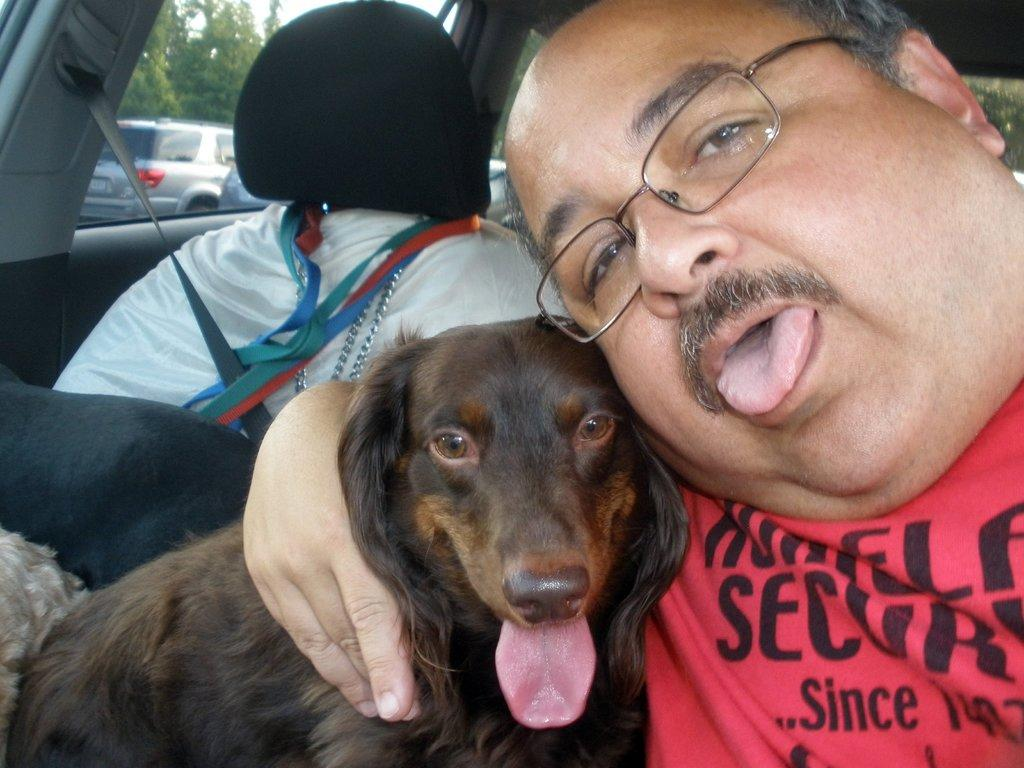What type of animal is present in the image? There is a dog in the image. Can you describe the man in the image? The man is wearing spectacles in the image. Where are the man and dog located? The man and dog are inside a vehicle. What can be seen from the vehicle in the image? Cars and trees are visible from the vehicle. What is the name of the sofa in the image? There is no sofa present in the image. How many quarters can be seen in the image? There are no quarters visible in the image. 